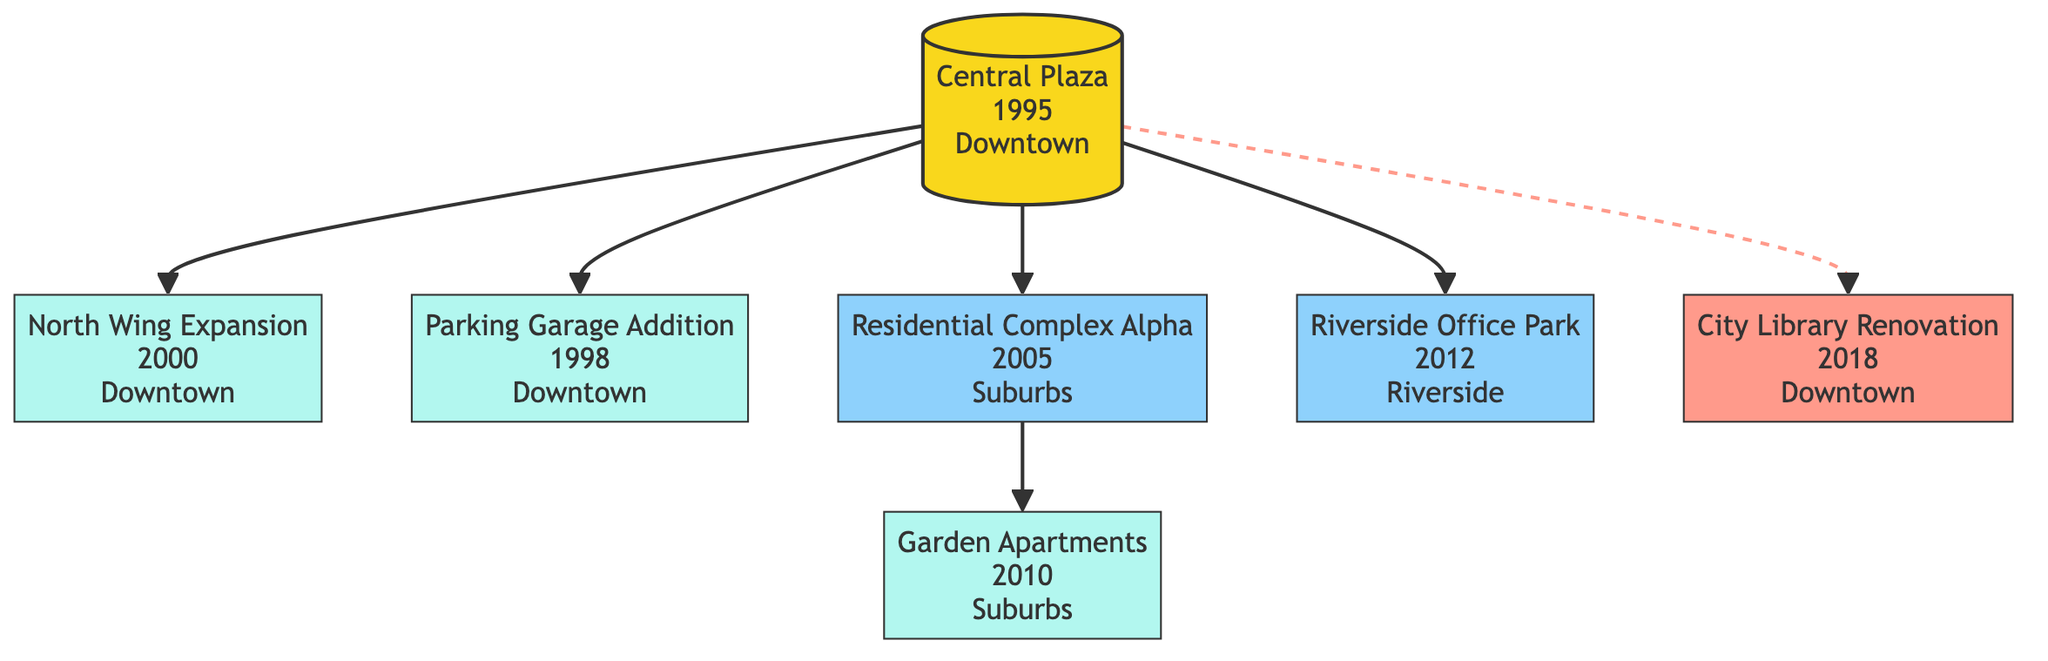What is the completion year of Central Plaza? The diagram indicates that Central Plaza is shown at the root of the family tree with its completion year noted beside its name. This year is explicitly listed as 1995.
Answer: 1995 How many sibling projects are there? Sibling projects are identified in the diagram as those directly linked to the root project without being a subproject. There are two sibling projects visible: Residential Complex Alpha and Riverside Office Park.
Answer: 2 What is the type of the North Wing Expansion? The diagram shows that the North Wing Expansion is categorized under "Type" beside its name. It is labeled as a "Commercial Expansion."
Answer: Commercial Expansion Which project is related to Central Plaza by joint venture? Under Related Projects in the diagram, the City Library Renovation is specifically marked as having a relationship with Central Plaza through a joint venture.
Answer: City Library Renovation What is the location of the Garden Apartments? The Garden Apartments is a subproject of Residential Complex Alpha in the diagram. The location is specified as "Suburbs" indicated next to its name.
Answer: Suburbs How many subprojects does the Residential Complex Alpha have? By examining the diagram, we see that Residential Complex Alpha has one subproject linked to it, which is the Garden Apartments. This indicates there is one child project.
Answer: 1 What type of project is the Riverside Office Park? The diagram provides a clear label for the Riverside Office Park indicating its type. It is categorized as a "Commercial Building."
Answer: Commercial Building Which project comes after the Parking Garage Addition in terms of completion year? Looking at the completion years listed in the diagram, the Parking Garage Addition was completed in 1998, and the next project after it in the diagram is North Wing Expansion, completed in 2000.
Answer: North Wing Expansion What type of relationship does the City Library Renovation have with Central Plaza? The diagram specifies the relationship between the City Library Renovation and Central Plaza as "JointVenture," clearly indicating this connection.
Answer: JointVenture 